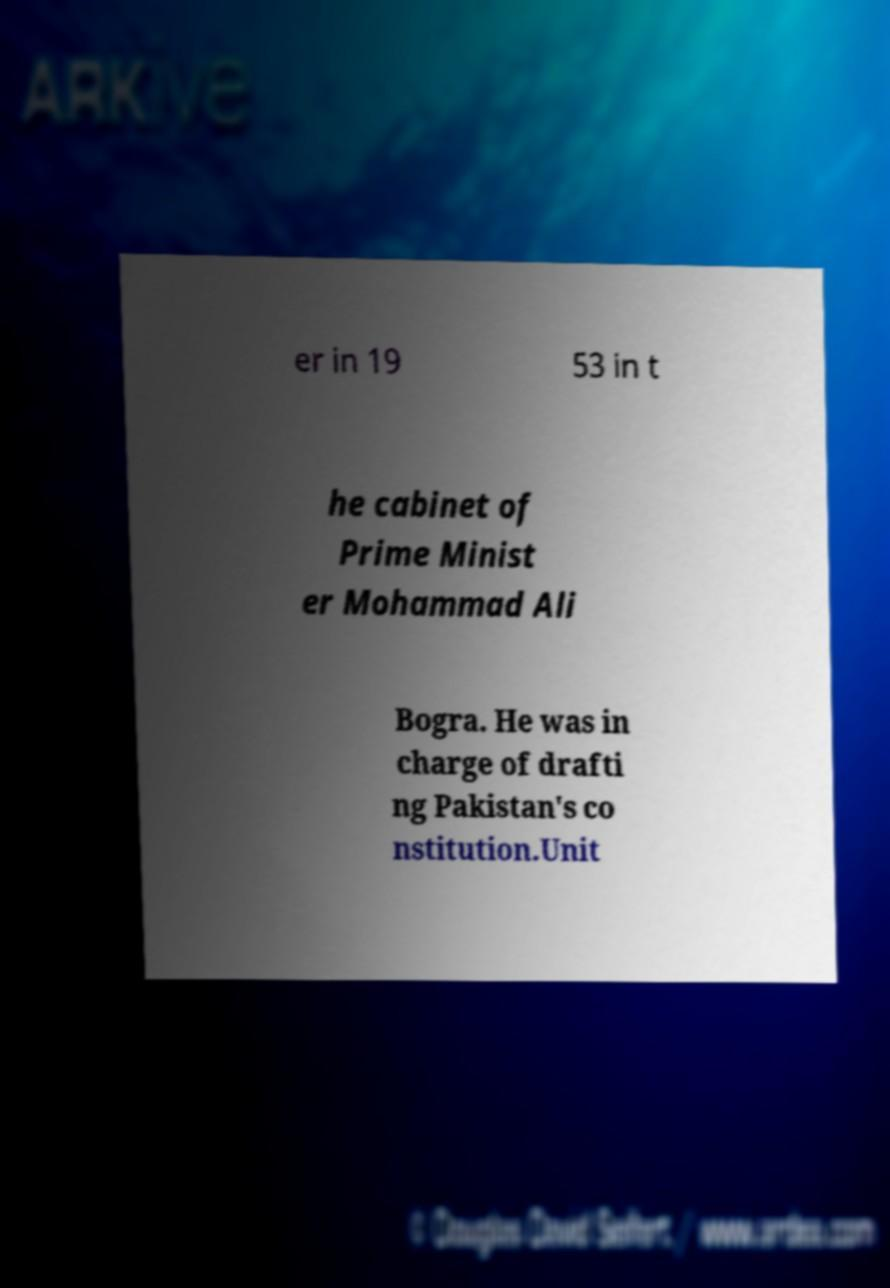Please identify and transcribe the text found in this image. er in 19 53 in t he cabinet of Prime Minist er Mohammad Ali Bogra. He was in charge of drafti ng Pakistan's co nstitution.Unit 